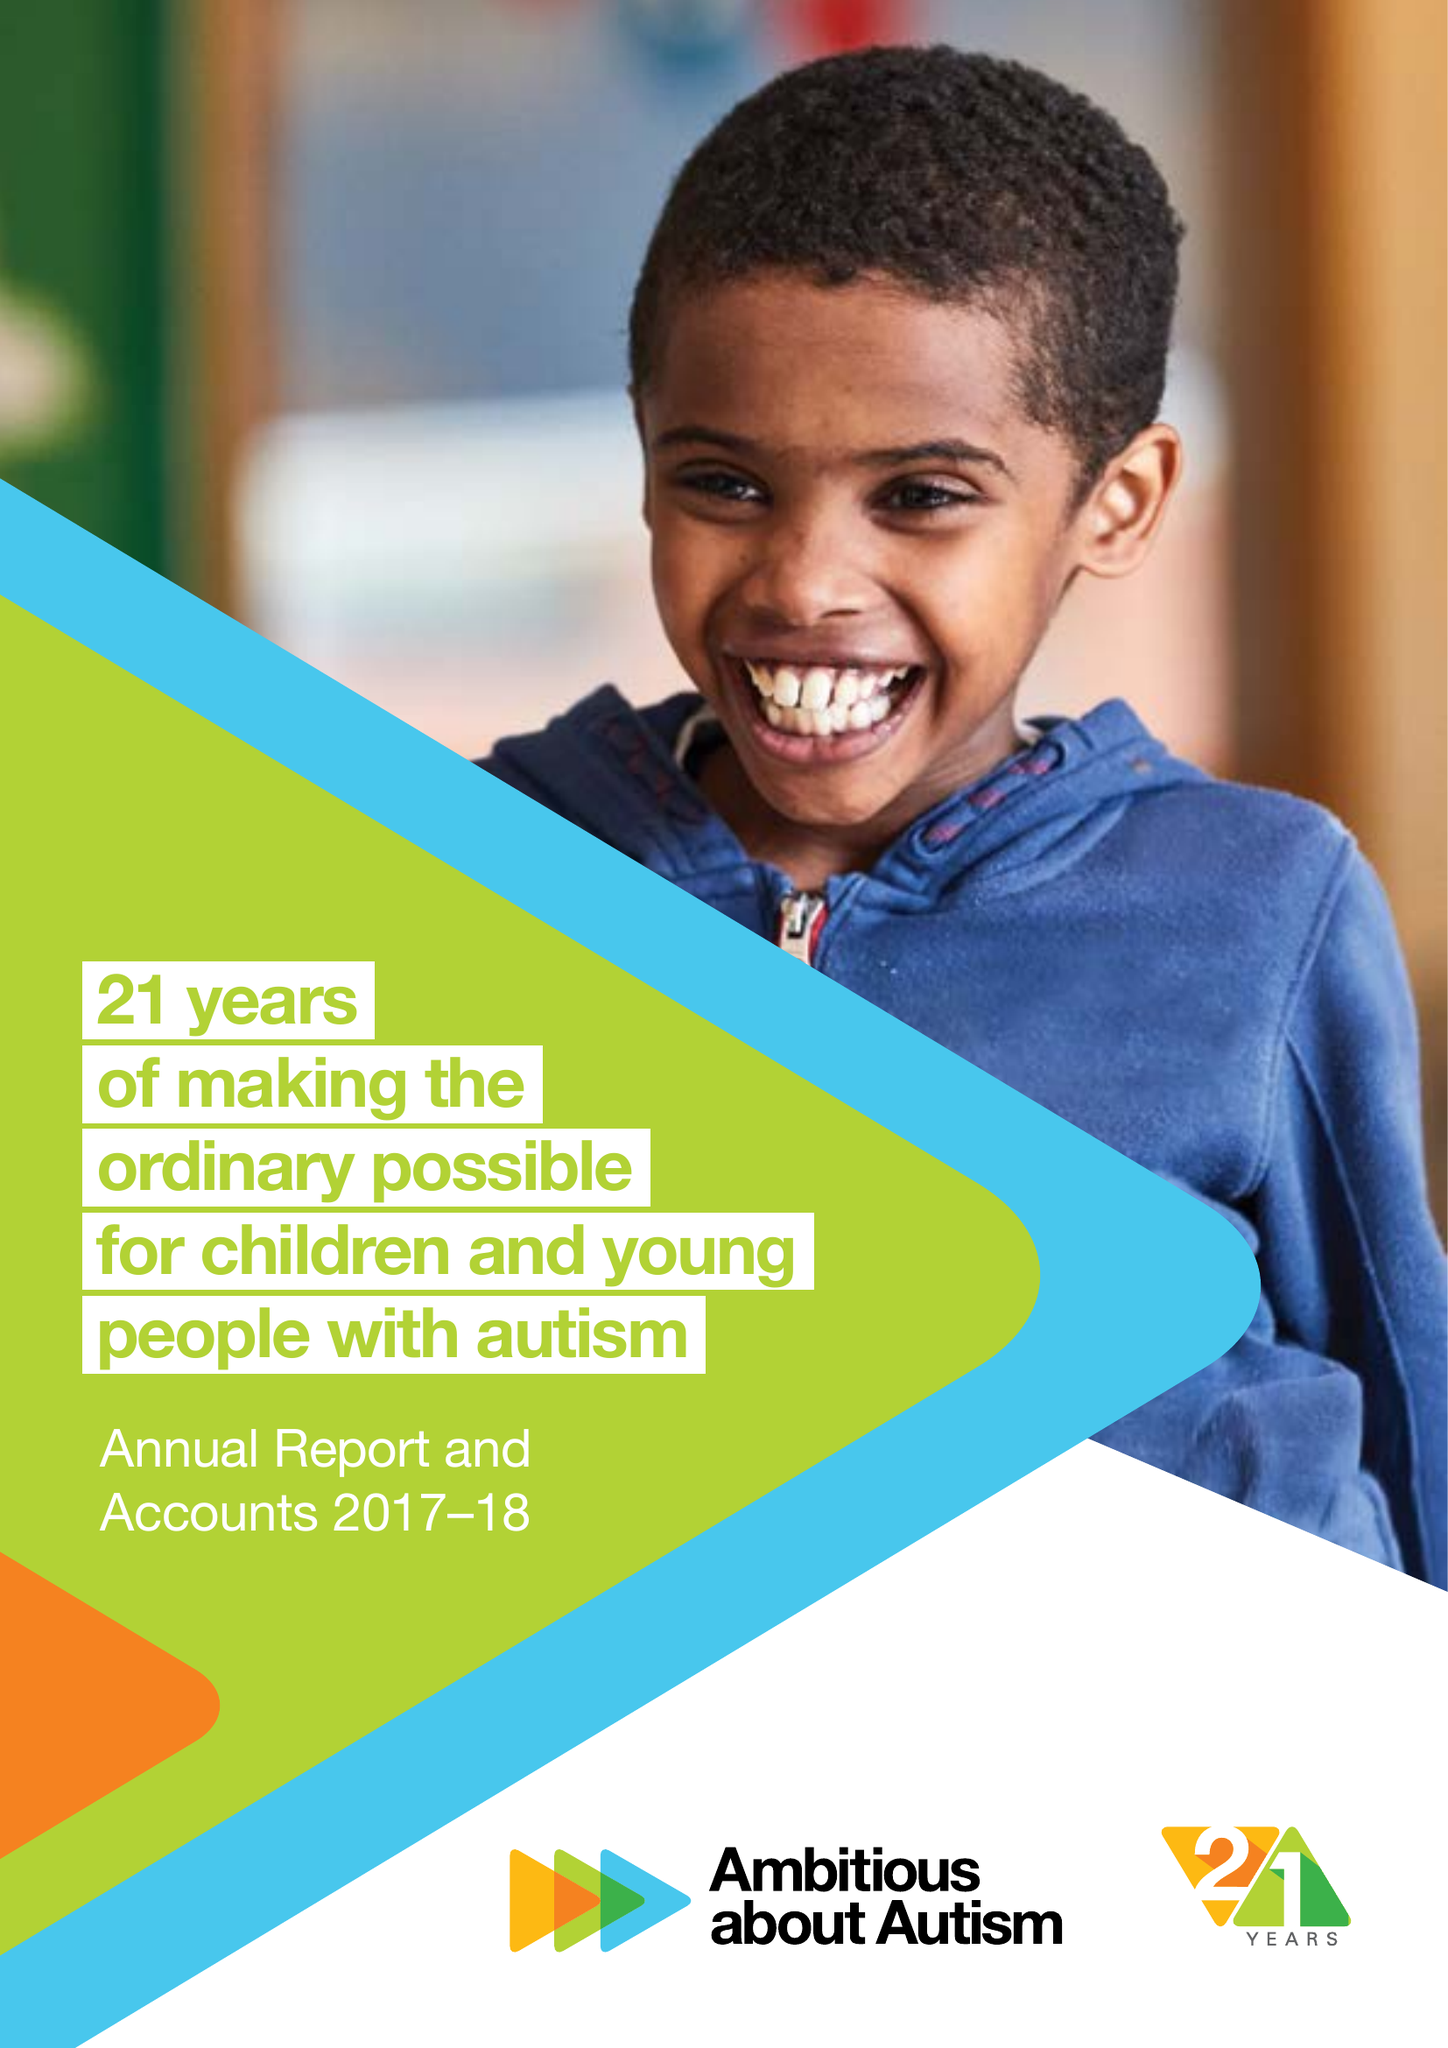What is the value for the report_date?
Answer the question using a single word or phrase. 2018-08-31 